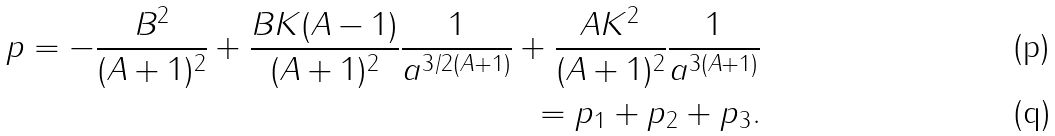Convert formula to latex. <formula><loc_0><loc_0><loc_500><loc_500>p = - \frac { B ^ { 2 } } { ( A + 1 ) ^ { 2 } } + \frac { B K ( A - 1 ) } { ( A + 1 ) ^ { 2 } } \frac { 1 } { a ^ { 3 / 2 ( A + 1 ) } } + \frac { A K ^ { 2 } } { ( A + 1 ) ^ { 2 } } \frac { 1 } { a ^ { 3 ( A + 1 ) } } \\ = p _ { 1 } + p _ { 2 } + p _ { 3 } .</formula> 